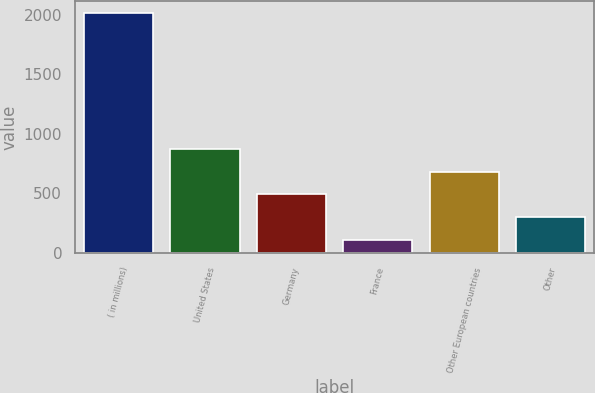<chart> <loc_0><loc_0><loc_500><loc_500><bar_chart><fcel>( in millions)<fcel>United States<fcel>Germany<fcel>France<fcel>Other European countries<fcel>Other<nl><fcel>2013<fcel>872.76<fcel>492.68<fcel>112.6<fcel>682.72<fcel>302.64<nl></chart> 